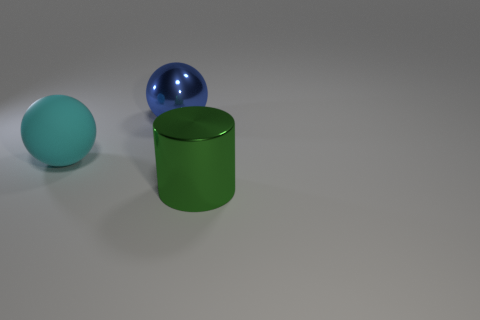Does the large metal cylinder have the same color as the matte object?
Provide a short and direct response. No. Are there any other things that have the same material as the large blue thing?
Give a very brief answer. Yes. How many objects are large cylinders or metallic things behind the shiny cylinder?
Make the answer very short. 2. There is a metal object that is behind the green object; does it have the same size as the large cylinder?
Offer a terse response. Yes. How many other objects are there of the same shape as the large green thing?
Provide a succinct answer. 0. What number of yellow things are either metallic things or large cylinders?
Your answer should be compact. 0. There is a metal thing behind the cylinder; is it the same color as the matte sphere?
Ensure brevity in your answer.  No. There is a large thing that is made of the same material as the green cylinder; what shape is it?
Give a very brief answer. Sphere. There is a thing that is right of the cyan rubber sphere and left of the green cylinder; what color is it?
Ensure brevity in your answer.  Blue. What size is the thing that is left of the big metallic thing on the left side of the metallic cylinder?
Your answer should be compact. Large. 